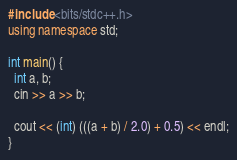Convert code to text. <code><loc_0><loc_0><loc_500><loc_500><_C++_>#include <bits/stdc++.h>
using namespace std;
 
int main() {
  int a, b;
  cin >> a >> b;
  
  cout << (int) (((a + b) / 2.0) + 0.5) << endl;
}</code> 